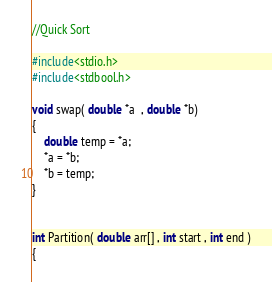<code> <loc_0><loc_0><loc_500><loc_500><_C_>//Quick Sort

#include<stdio.h>
#include<stdbool.h>

void swap( double *a  , double *b)
{
    double temp = *a;
    *a = *b;
    *b = temp;
}


int Partition( double arr[] , int start , int end )
{</code> 